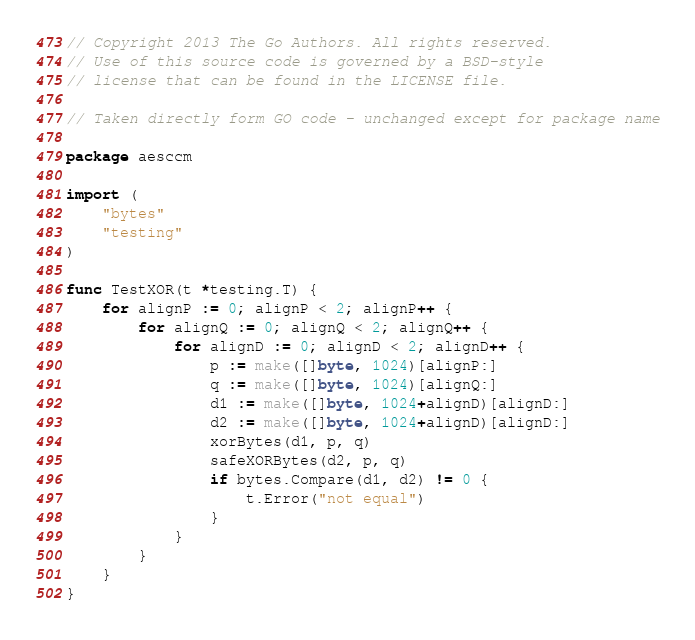Convert code to text. <code><loc_0><loc_0><loc_500><loc_500><_Go_>// Copyright 2013 The Go Authors. All rights reserved.
// Use of this source code is governed by a BSD-style
// license that can be found in the LICENSE file.

// Taken directly form GO code - unchanged except for package name

package aesccm

import (
	"bytes"
	"testing"
)

func TestXOR(t *testing.T) {
	for alignP := 0; alignP < 2; alignP++ {
		for alignQ := 0; alignQ < 2; alignQ++ {
			for alignD := 0; alignD < 2; alignD++ {
				p := make([]byte, 1024)[alignP:]
				q := make([]byte, 1024)[alignQ:]
				d1 := make([]byte, 1024+alignD)[alignD:]
				d2 := make([]byte, 1024+alignD)[alignD:]
				xorBytes(d1, p, q)
				safeXORBytes(d2, p, q)
				if bytes.Compare(d1, d2) != 0 {
					t.Error("not equal")
				}
			}
		}
	}
}
</code> 